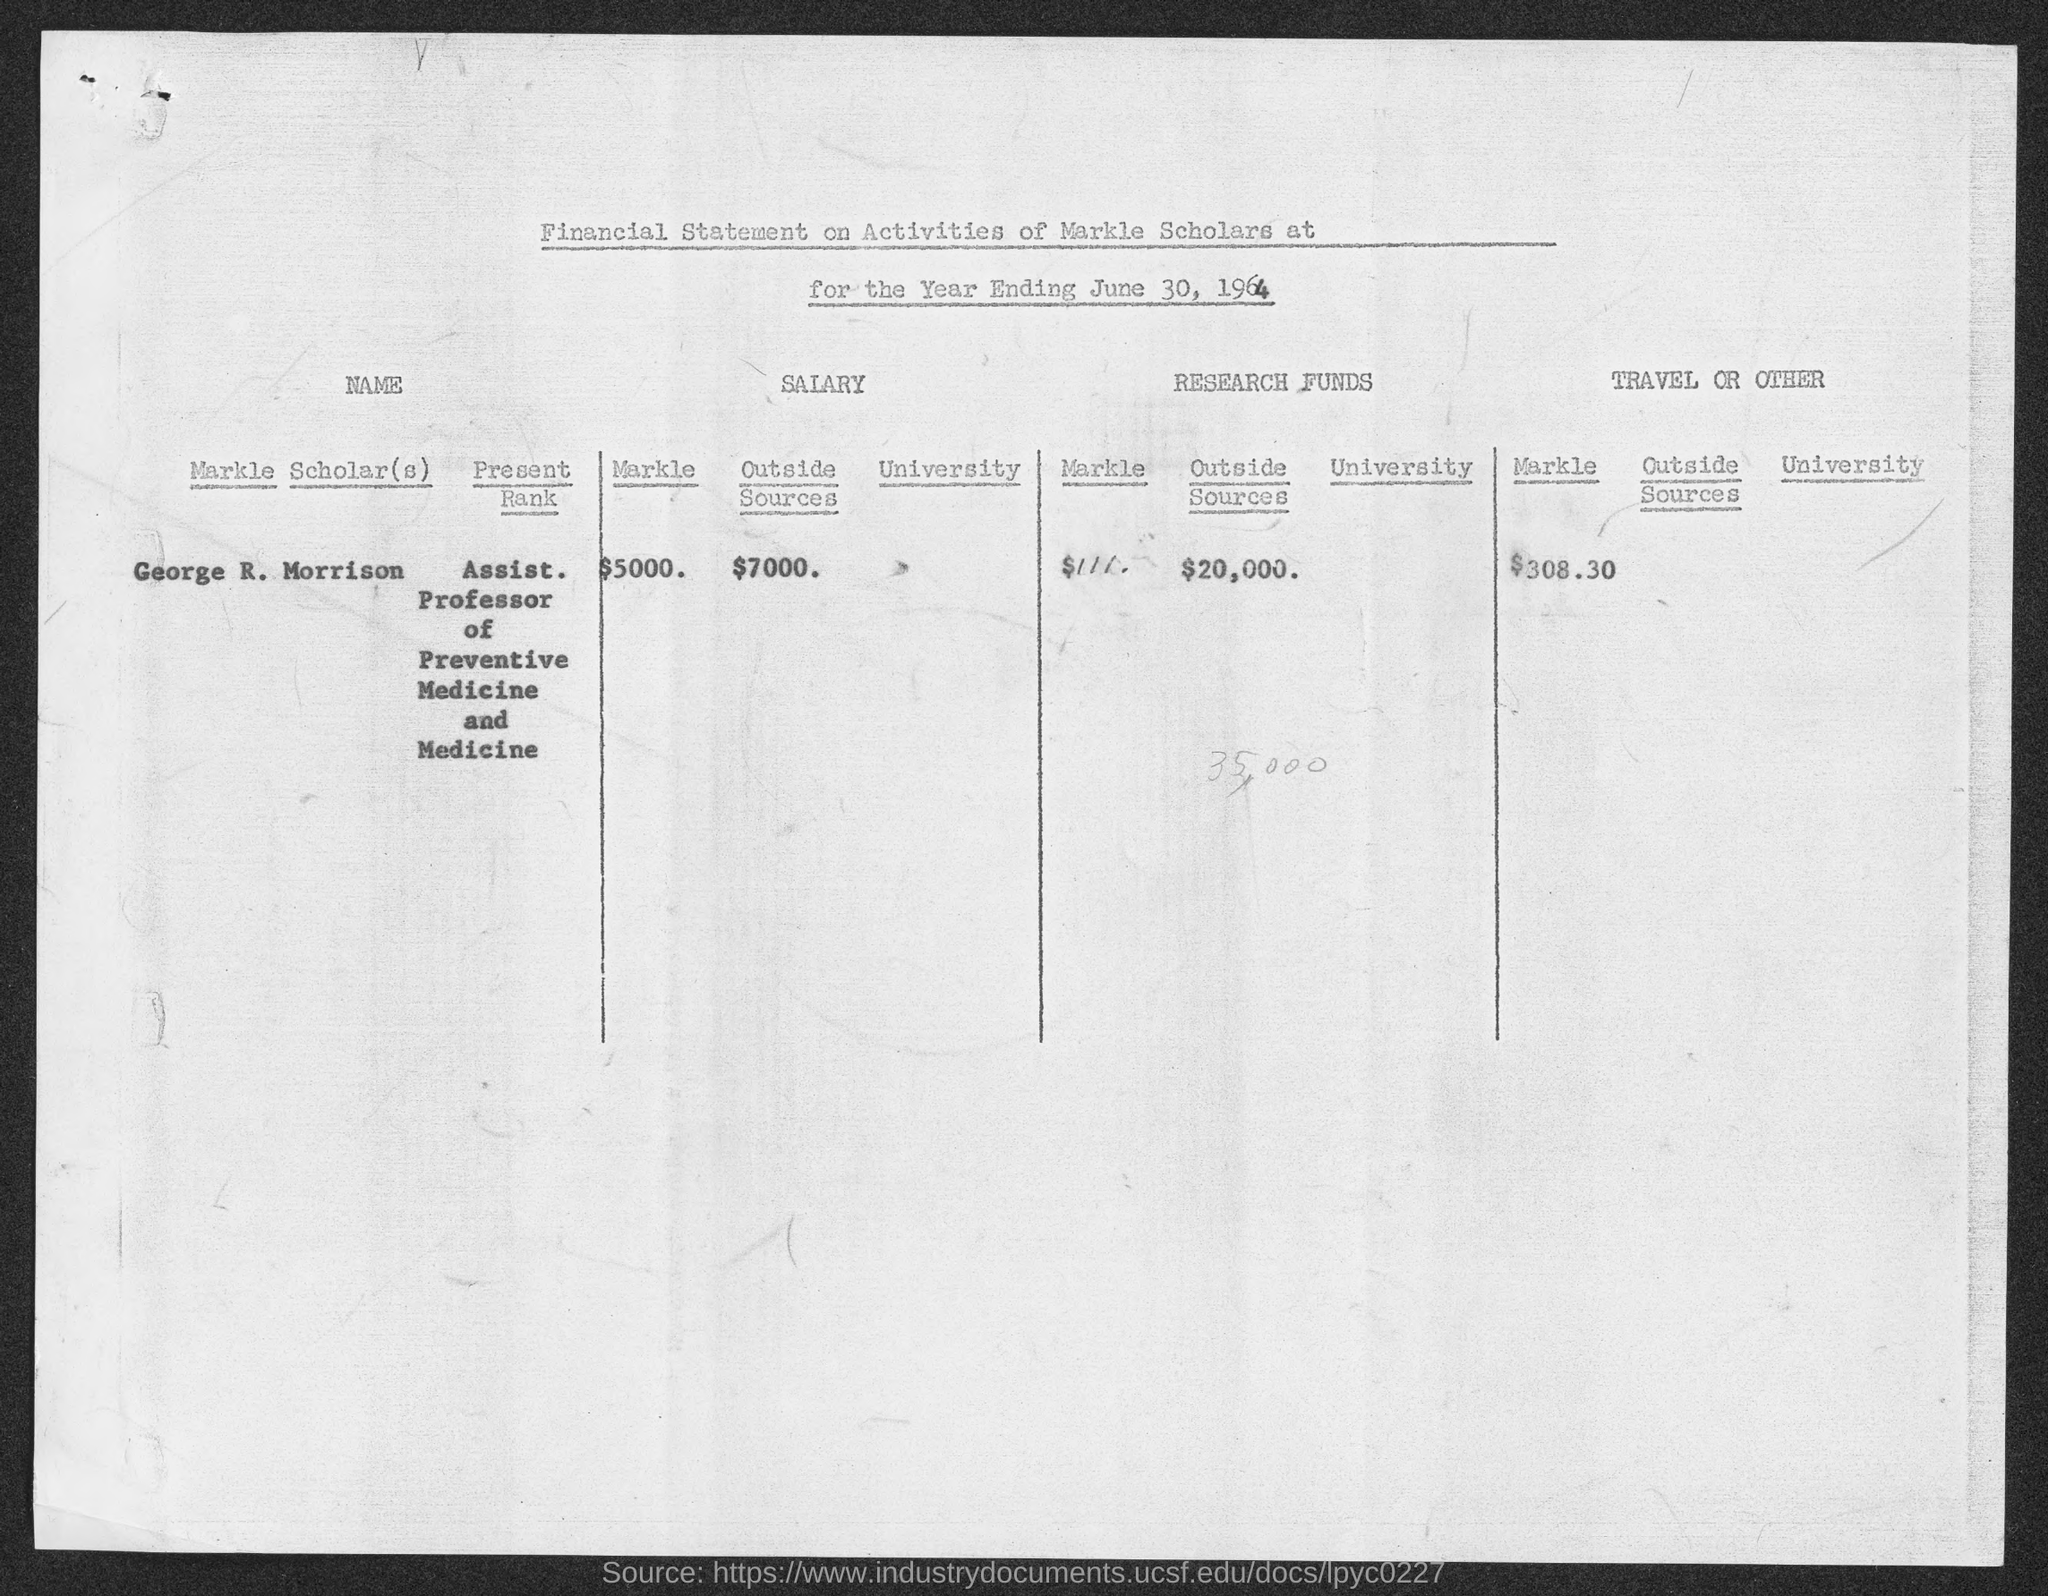What is the amount spent on other expences?
Your response must be concise. $308.30. How much money spent on Research Funds?
Make the answer very short. $20,000. What is total salary of Markle Scholar
Provide a succinct answer. $5,000. What is the name of the Scholar?
Your answer should be very brief. George R. Morrison. What is the Financial Year Ending Date of Markle?
Your answer should be very brief. June 30, 1964. What is the Scholar's Rank mentioned here?
Offer a very short reply. Assist. Professor of Preventive Medicine and Medicine. 